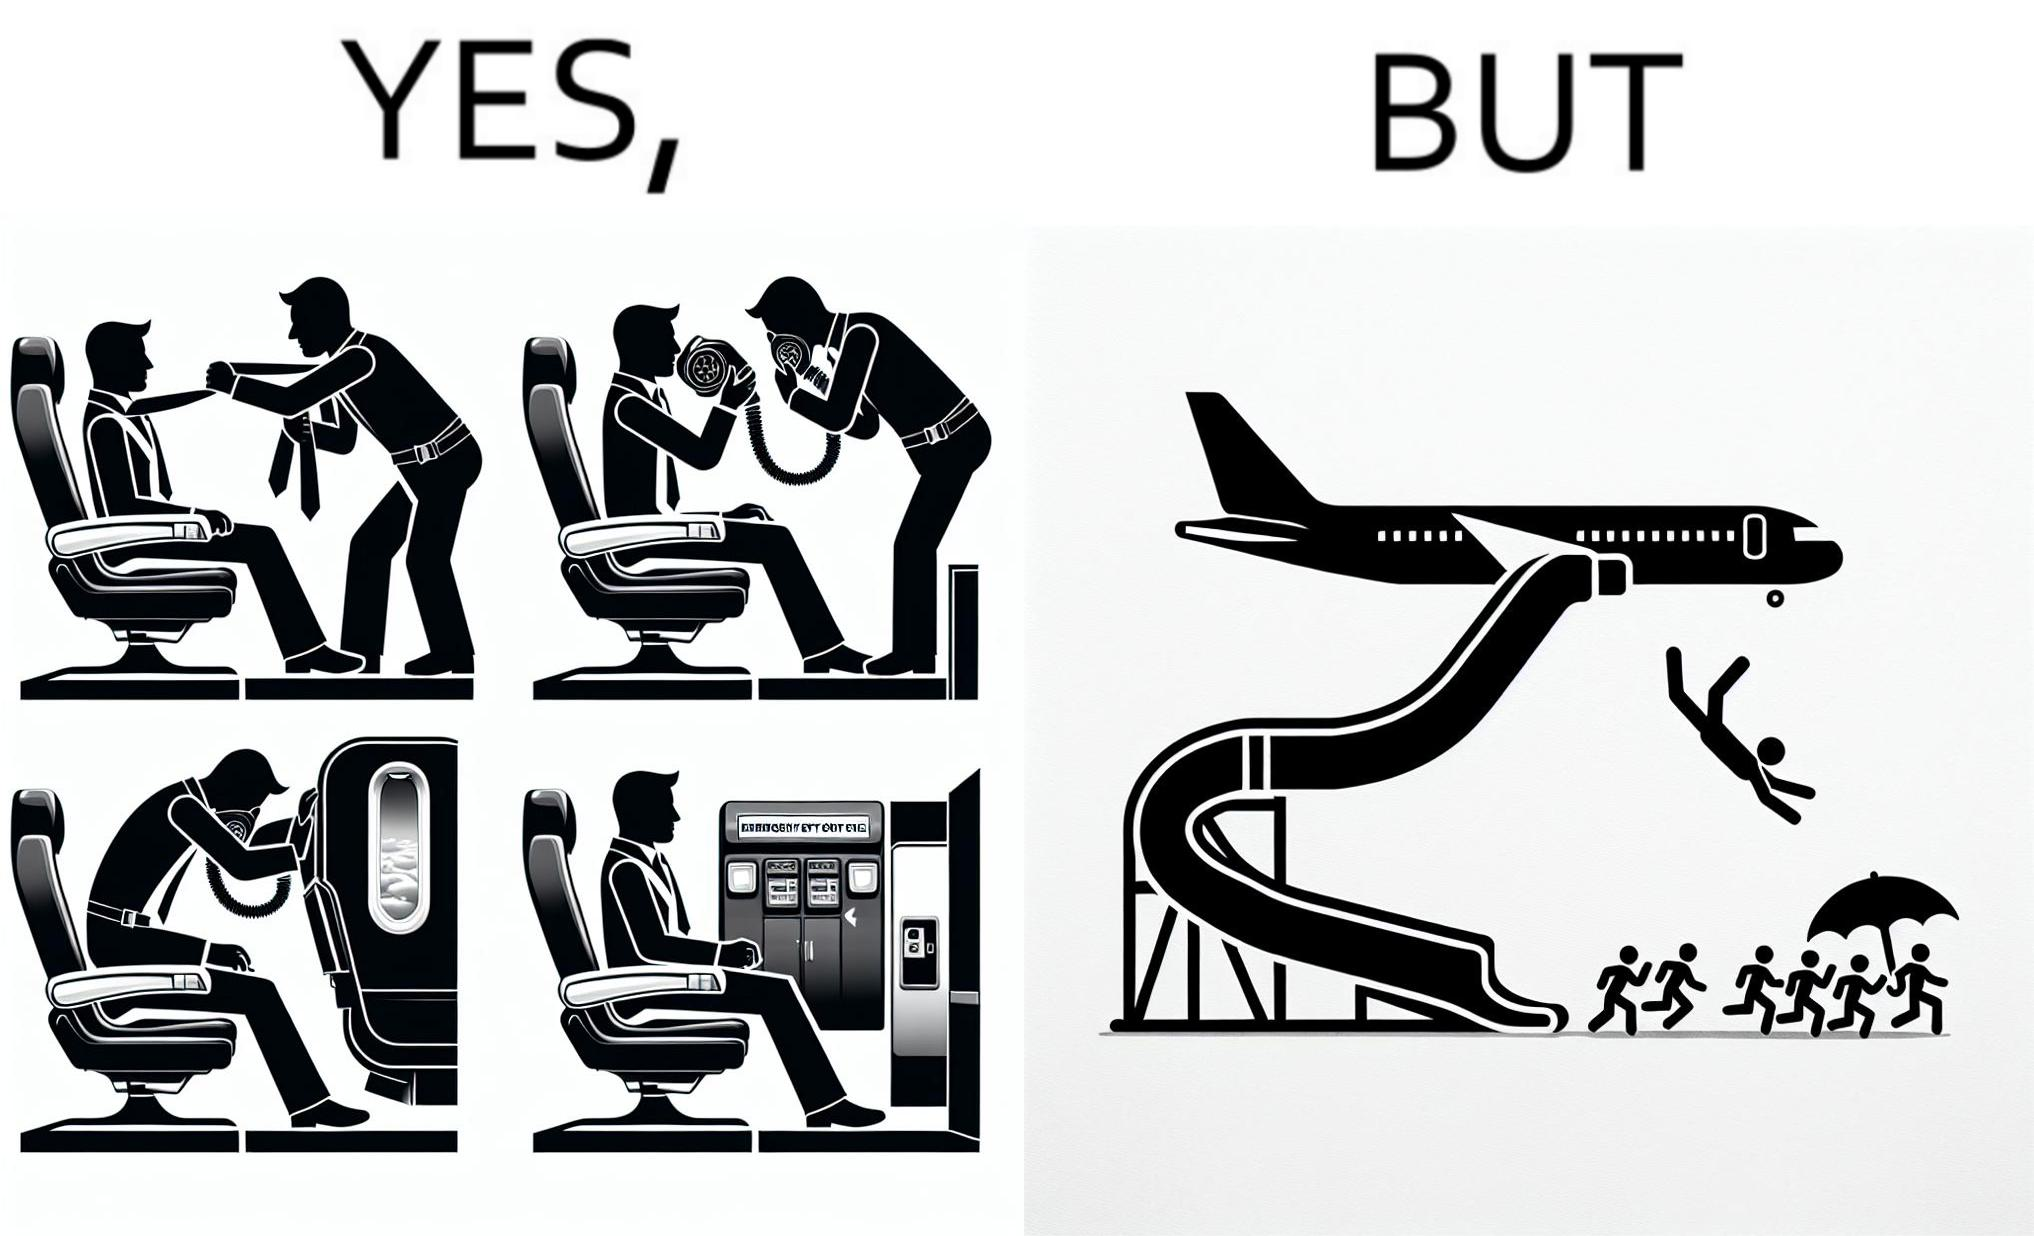What is shown in this image? These images are funny since it shows how we are taught emergency procedures to follow in case of an accident while in an airplane but how none of them work if the plane is still in air 